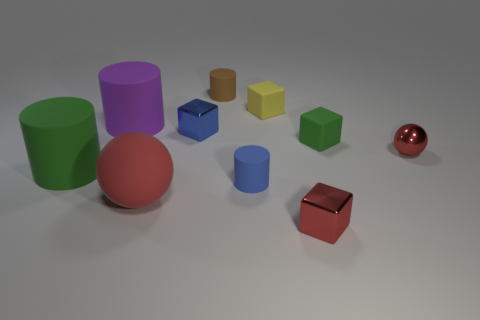Are there more purple things on the right side of the large green matte object than tiny purple metal blocks?
Give a very brief answer. Yes. How many things are either tiny blue matte cylinders left of the small red metallic sphere or matte cylinders that are on the right side of the large red sphere?
Give a very brief answer. 2. What size is the blue cylinder that is made of the same material as the big green cylinder?
Provide a short and direct response. Small. There is a red shiny thing that is behind the big green matte thing; is its shape the same as the yellow thing?
Ensure brevity in your answer.  No. There is another ball that is the same color as the big rubber ball; what size is it?
Your answer should be very brief. Small. What number of green objects are small objects or tiny cylinders?
Make the answer very short. 1. What number of other objects are the same shape as the large green rubber object?
Provide a short and direct response. 3. The rubber object that is behind the tiny sphere and to the left of the small brown thing has what shape?
Make the answer very short. Cylinder. There is a large sphere; are there any big red rubber things on the right side of it?
Offer a terse response. No. What size is the yellow rubber object that is the same shape as the tiny green object?
Give a very brief answer. Small. 